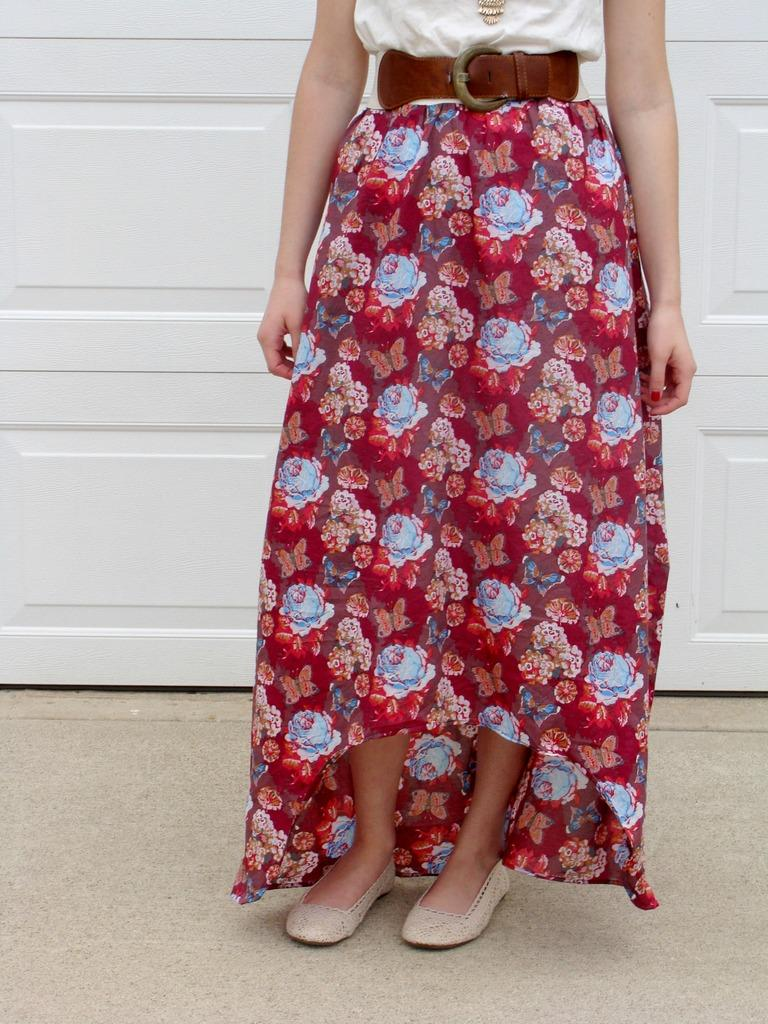What is the main subject of the image? The main subject of the image is a woman. What type of clothing is the woman wearing? The woman is wearing a skirt. Are there any accessories visible in the image? Yes, the woman is wearing a brown belt. What type of vessel is the woman holding in the image? There is no vessel present in the image; the woman is not holding anything. 